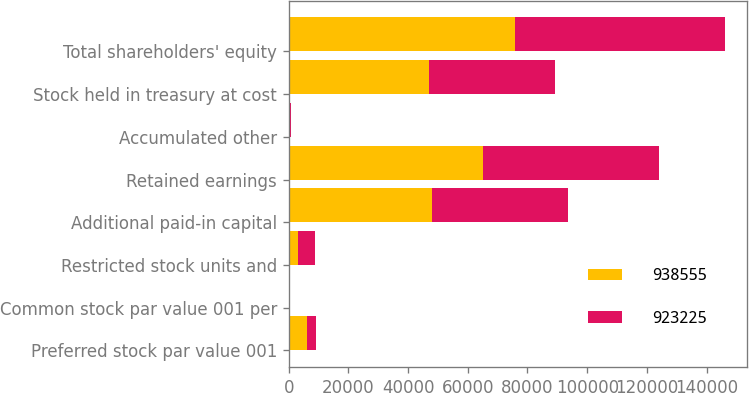<chart> <loc_0><loc_0><loc_500><loc_500><stacked_bar_chart><ecel><fcel>Preferred stock par value 001<fcel>Common stock par value 001 per<fcel>Restricted stock units and<fcel>Additional paid-in capital<fcel>Retained earnings<fcel>Accumulated other<fcel>Stock held in treasury at cost<fcel>Total shareholders' equity<nl><fcel>938555<fcel>6200<fcel>8<fcel>3298<fcel>48030<fcel>65223<fcel>193<fcel>46850<fcel>75716<nl><fcel>923225<fcel>3100<fcel>8<fcel>5681<fcel>45553<fcel>58834<fcel>516<fcel>42281<fcel>70379<nl></chart> 